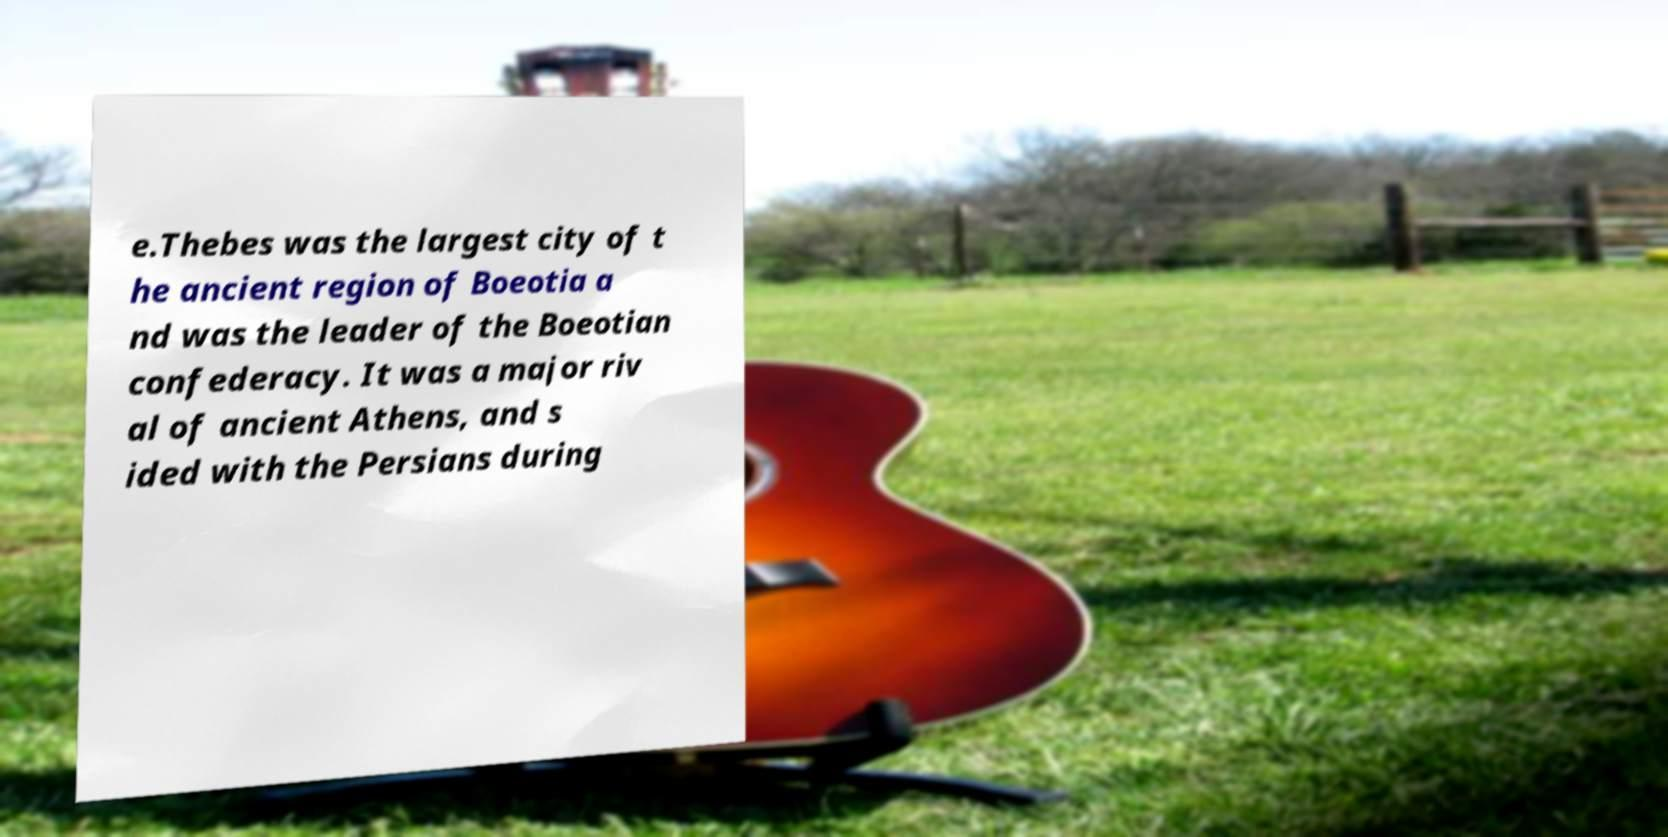There's text embedded in this image that I need extracted. Can you transcribe it verbatim? e.Thebes was the largest city of t he ancient region of Boeotia a nd was the leader of the Boeotian confederacy. It was a major riv al of ancient Athens, and s ided with the Persians during 